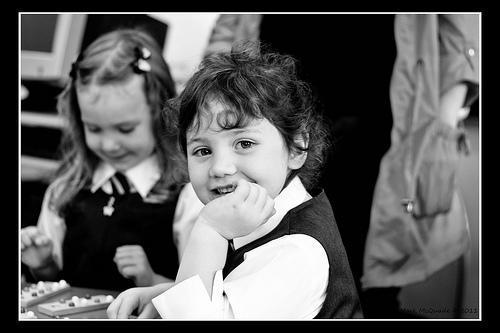How many adults do you see?
Give a very brief answer. 1. How many people are looking at the camera?
Give a very brief answer. 1. How many children are shown?
Give a very brief answer. 2. 